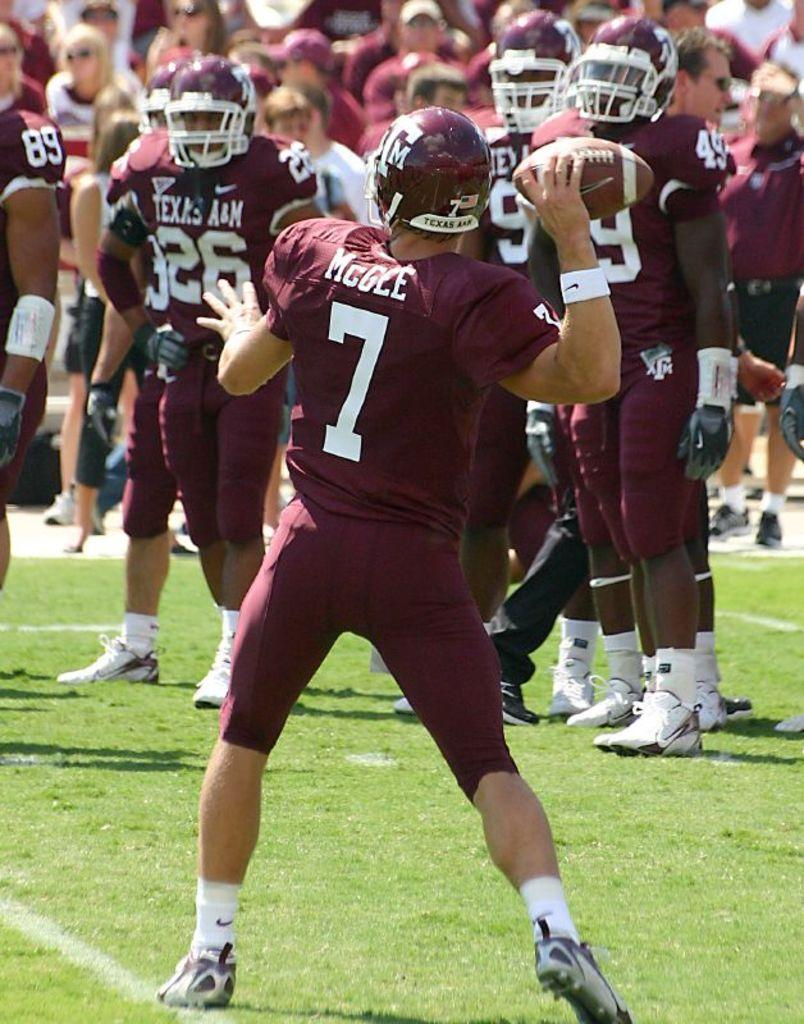What is the main subject of the image? There is a person standing in the image. What is the person doing in the image? The person is throwing a ball. Where is the ball located in the image? The ball is in the middle of the image. Are there any other people visible in the image? Yes, there are other persons standing in the background of the image. What type of drug is the person taking in the image? There is no indication of any drug in the image; the person is throwing a ball. What is the range of the person's throw in the image? The image does not provide information about the range of the person's throw. 